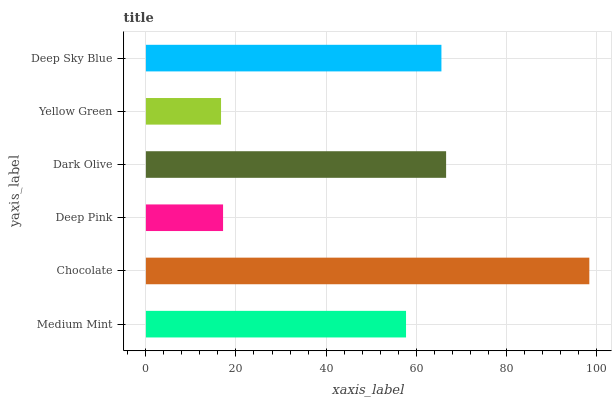Is Yellow Green the minimum?
Answer yes or no. Yes. Is Chocolate the maximum?
Answer yes or no. Yes. Is Deep Pink the minimum?
Answer yes or no. No. Is Deep Pink the maximum?
Answer yes or no. No. Is Chocolate greater than Deep Pink?
Answer yes or no. Yes. Is Deep Pink less than Chocolate?
Answer yes or no. Yes. Is Deep Pink greater than Chocolate?
Answer yes or no. No. Is Chocolate less than Deep Pink?
Answer yes or no. No. Is Deep Sky Blue the high median?
Answer yes or no. Yes. Is Medium Mint the low median?
Answer yes or no. Yes. Is Medium Mint the high median?
Answer yes or no. No. Is Chocolate the low median?
Answer yes or no. No. 